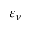Convert formula to latex. <formula><loc_0><loc_0><loc_500><loc_500>\varepsilon _ { \nu }</formula> 